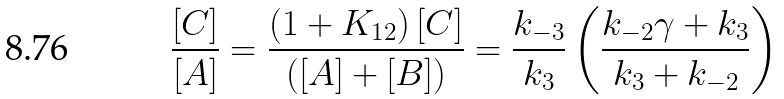Convert formula to latex. <formula><loc_0><loc_0><loc_500><loc_500>\frac { [ C ] } { [ A ] } = \frac { \left ( 1 + K _ { 1 2 } \right ) [ C ] } { ( [ A ] + [ B ] ) } = \frac { k _ { - 3 } } { k _ { 3 } } \left ( \frac { k _ { - 2 } \gamma + k _ { 3 } } { k _ { 3 } + k _ { - 2 } } \right )</formula> 